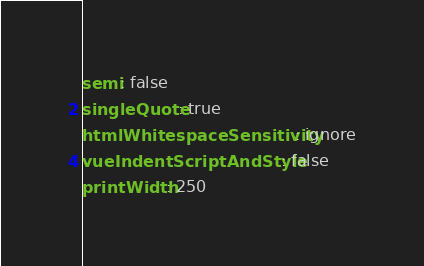<code> <loc_0><loc_0><loc_500><loc_500><_YAML_>semi: false
singleQuote: true
htmlWhitespaceSensitivity: ignore
vueIndentScriptAndStyle: false
printWidth: 250
</code> 